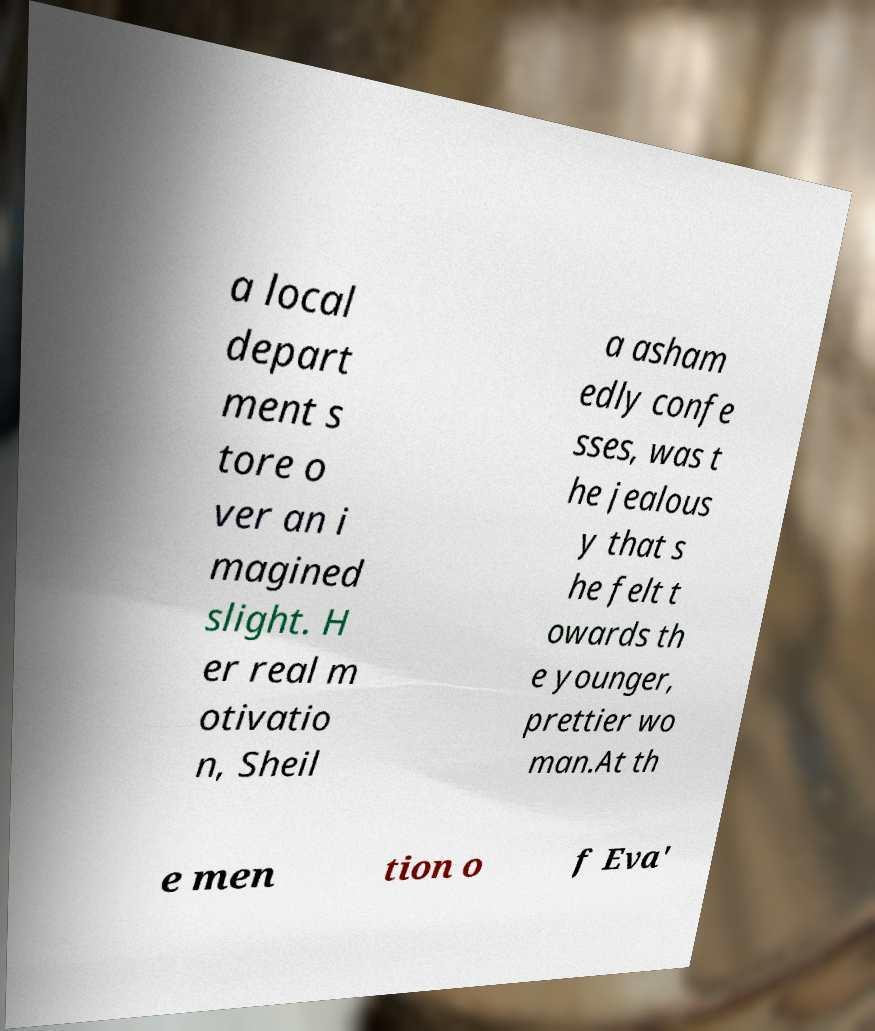Can you accurately transcribe the text from the provided image for me? a local depart ment s tore o ver an i magined slight. H er real m otivatio n, Sheil a asham edly confe sses, was t he jealous y that s he felt t owards th e younger, prettier wo man.At th e men tion o f Eva' 